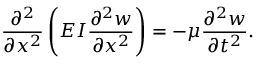<formula> <loc_0><loc_0><loc_500><loc_500>{ \frac { \partial ^ { 2 } } { \partial x ^ { 2 } } } \left ( E I { \frac { \partial ^ { 2 } w } { \partial x ^ { 2 } } } \right ) = - \mu { \frac { \partial ^ { 2 } w } { \partial t ^ { 2 } } } .</formula> 